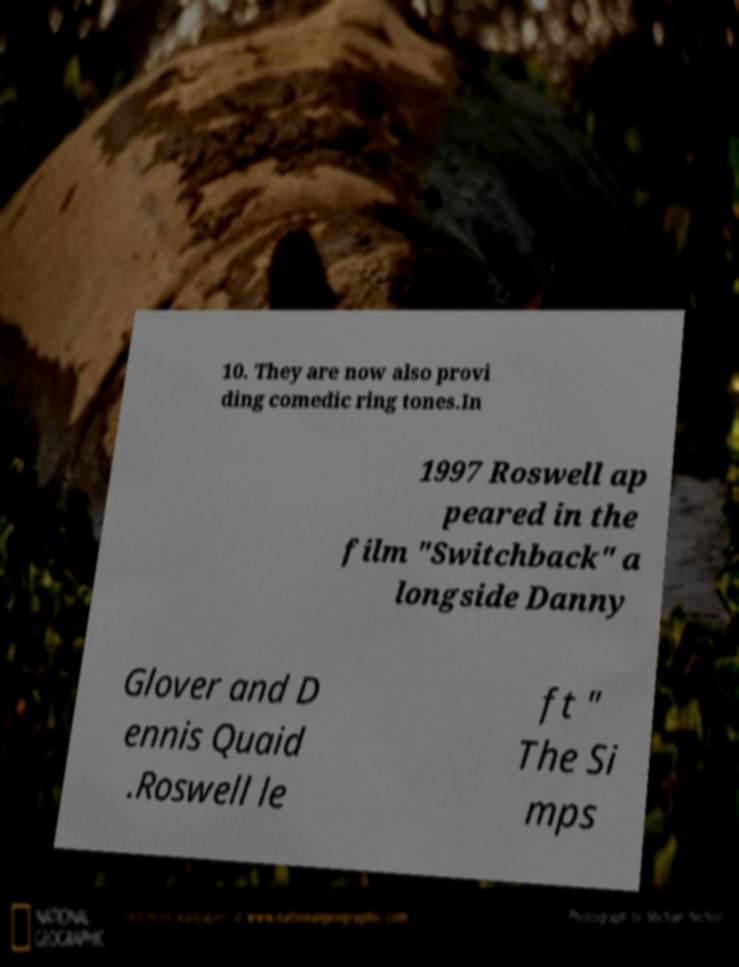I need the written content from this picture converted into text. Can you do that? 10. They are now also provi ding comedic ring tones.In 1997 Roswell ap peared in the film "Switchback" a longside Danny Glover and D ennis Quaid .Roswell le ft " The Si mps 